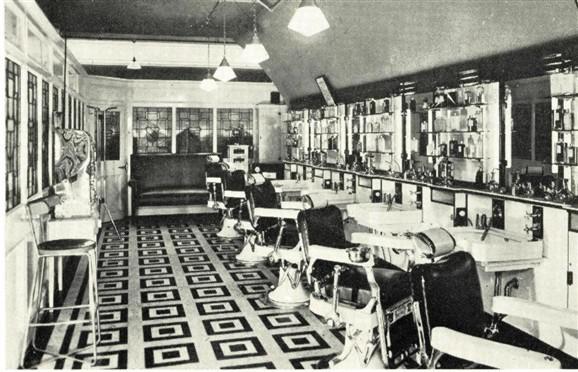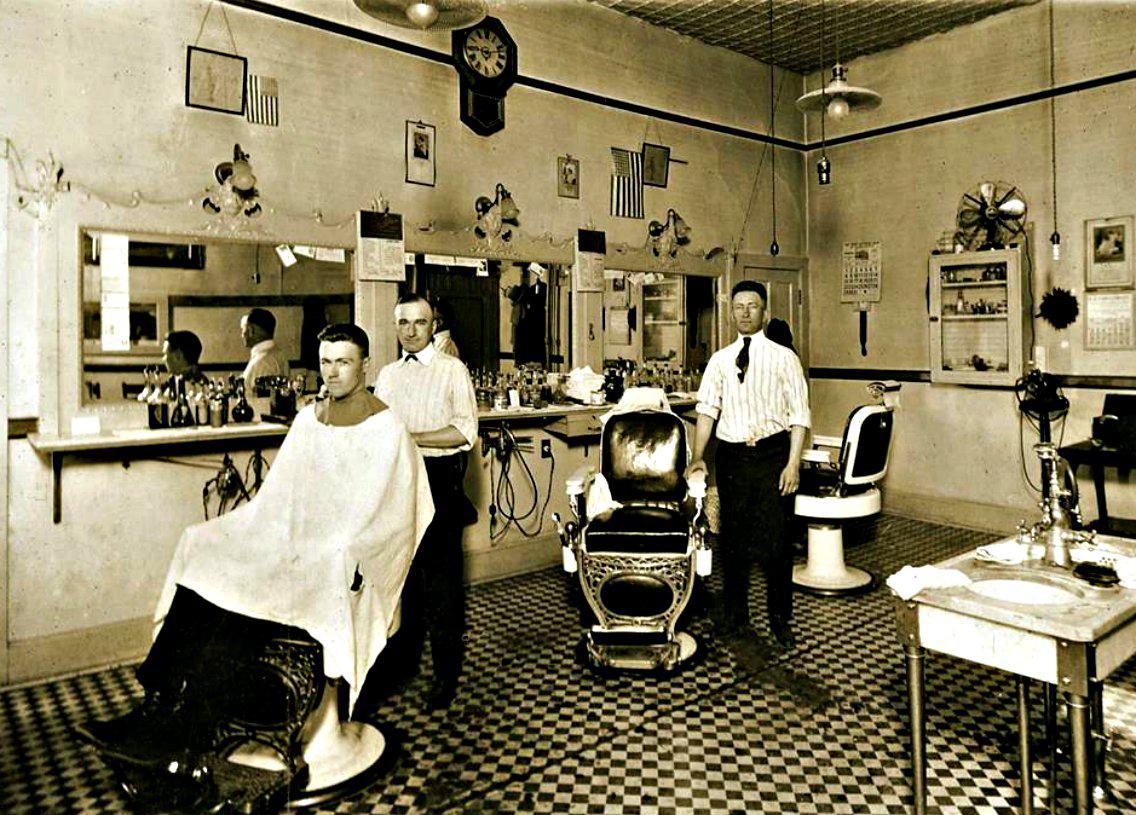The first image is the image on the left, the second image is the image on the right. Evaluate the accuracy of this statement regarding the images: "THere are exactly two people in the image on the left.". Is it true? Answer yes or no. No. The first image is the image on the left, the second image is the image on the right. Analyze the images presented: Is the assertion "In one image, one barber has a customer in his chair and one does not." valid? Answer yes or no. Yes. 